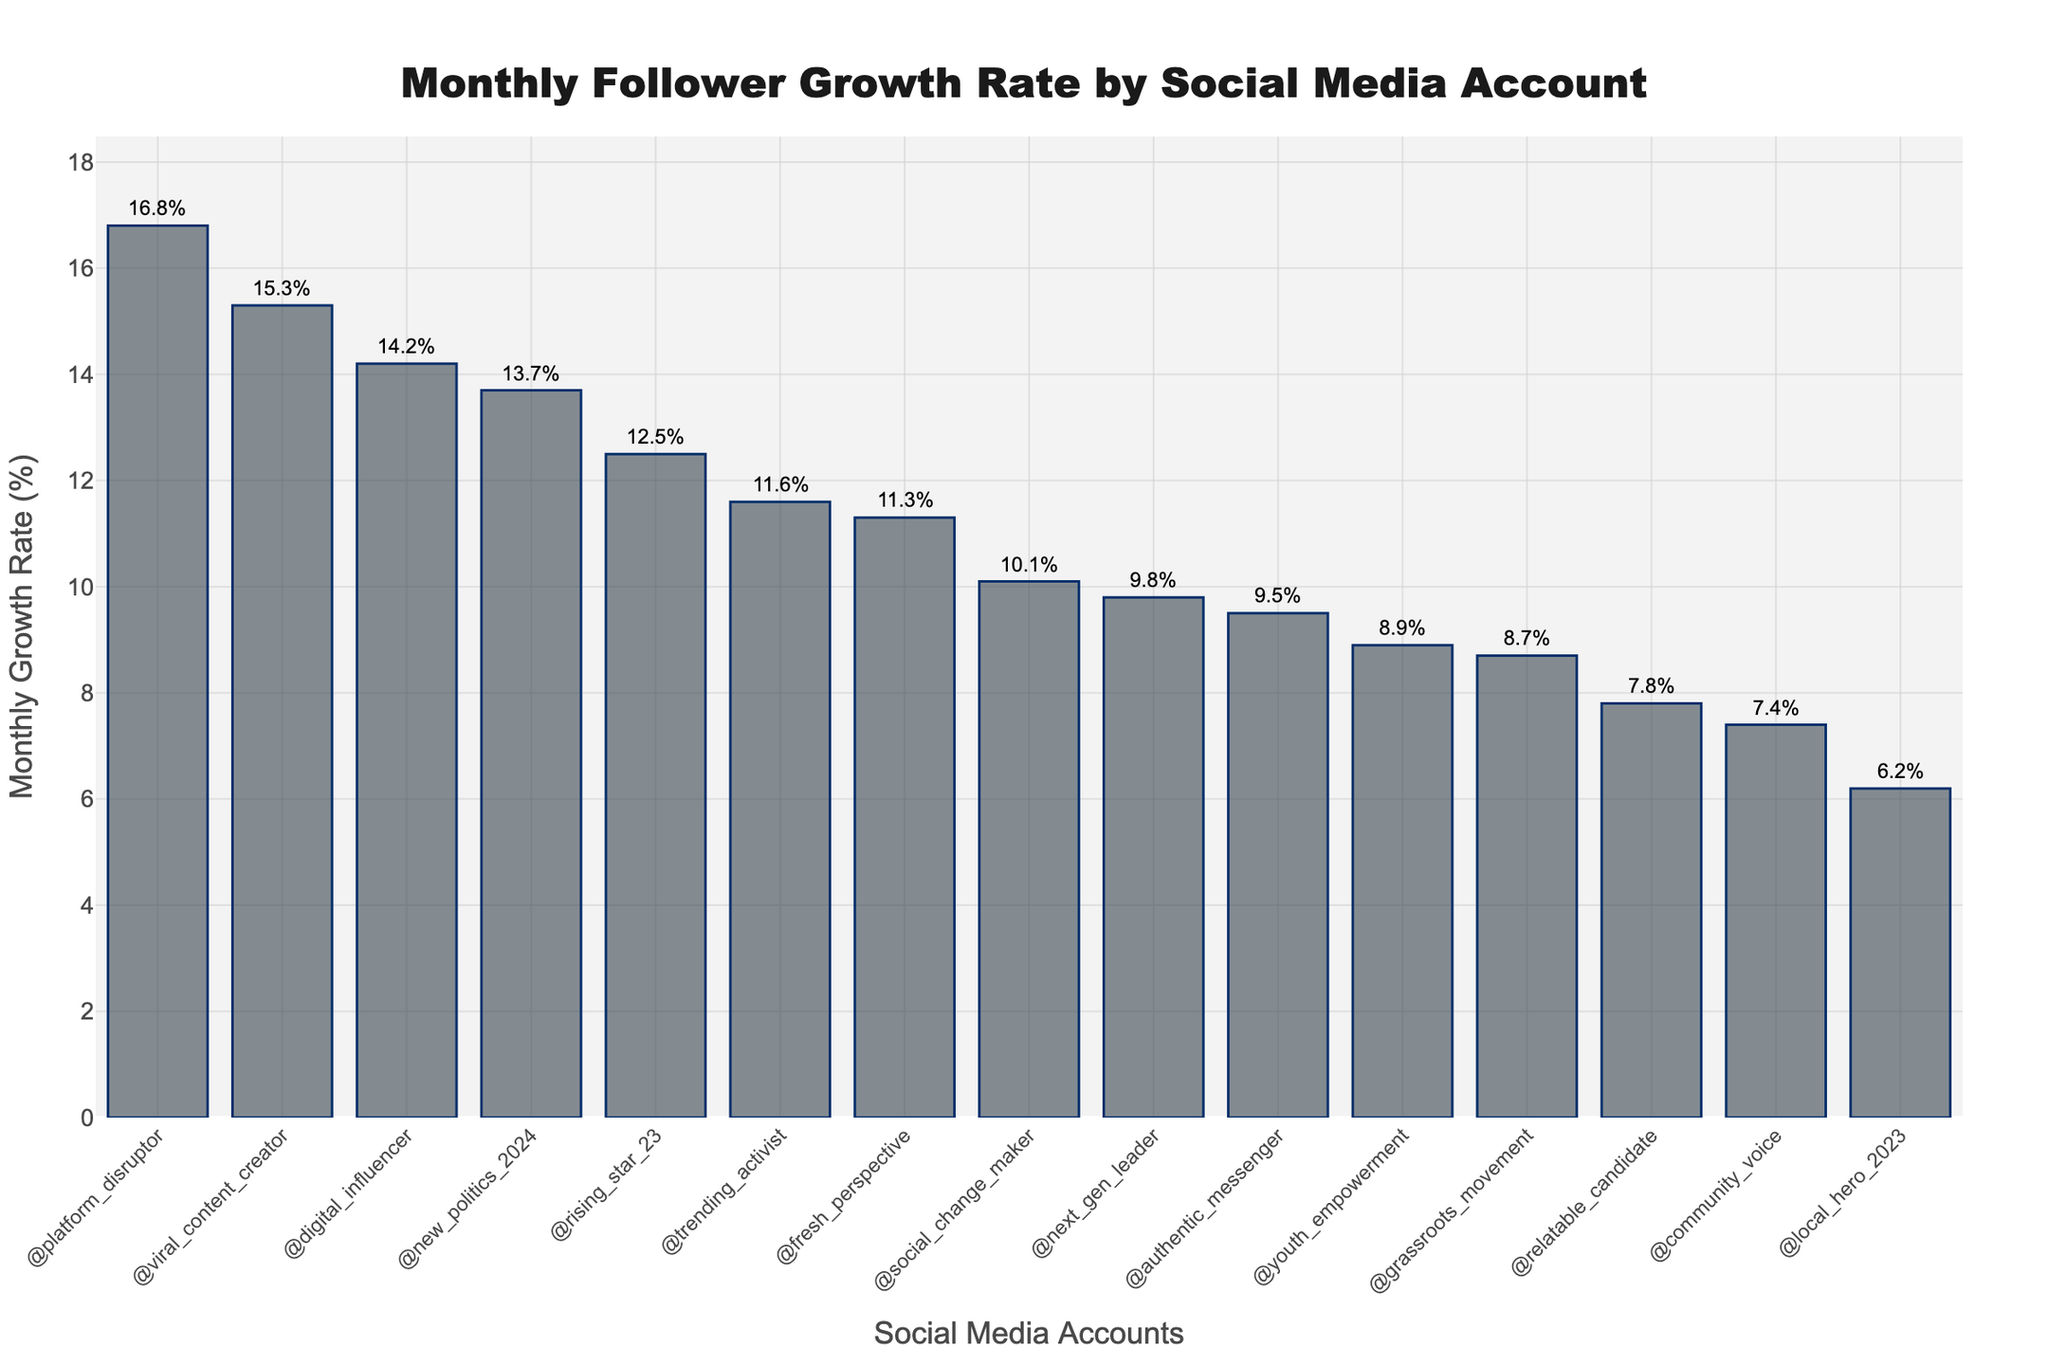Which social media account has the highest monthly follower growth rate? By inspecting the heights of the bars, the tallest bar represents the social media account with the highest growth rate. The account '@platform_disruptor' has the highest growth rate of 16.8%.
Answer: @platform_disruptor Which social media account has the lowest monthly follower growth rate? By inspecting the heights of the bars, the shortest bar represents the social media account with the lowest growth rate. The account '@local_hero_2023' has the lowest growth rate of 6.2%.
Answer: @local_hero_2023 What is the difference in monthly follower growth rates between @platform_disruptor and @local_hero_2023? The growth rates for '@platform_disruptor' and '@local_hero_2023' are 16.8% and 6.2%, respectively. Subtracting these values: 16.8% - 6.2% = 10.6%.
Answer: 10.6% Which account is growing faster, @rising_star_23 or @social_change_maker? Comparing the heights of the bars for '@rising_star_23' and '@social_change_maker', we see that '@rising_star_23' has a growth rate of 12.5% and '@social_change_maker' has a growth rate of 10.1%. Since 12.5% > 10.1%, '@rising_star_23' is growing faster.
Answer: @rising_star_23 What is the average monthly follower growth rate for all accounts? To find the average, sum all growth rates and divide by the number of accounts. The sum is 12.5 + 8.7 + 15.3 + 6.2 + 9.8 + 7.4 + 11.6 + 10.1 + 14.2 + 8.9 + 13.7 + 9.5 + 16.8 + 7.8 + 11.3 = 164.8%. There are 15 accounts, so the average is 164.8 / 15 ≈ 11.0%.
Answer: 11.0% How many accounts have a monthly growth rate greater than 10%? By identifying the bars whose heights correspond to a rate greater than 10%, we find 9 accounts: '@rising_star_23', '@viral_content_creator', '@next_gen_leader', '@trending_activist', '@social_change_maker', '@digital_influencer', '@new_politics_2024', '@platform_disruptor', and '@fresh_perspective'.
Answer: 9 What is the median monthly follower growth rate? To find the median, first, list all growth rates in ascending order: 6.2%, 7.4%, 7.8%, 8.7%, 8.9%, 9.5%, 9.8%, 10.1%, 11.3%, 11.6%, 12.5%, 13.7%, 14.2%, 15.3%, 16.8%. The median is the 8th value since there are 15 values in total. Hence, the median growth rate is 10.1%.
Answer: 10.1% Which account has a growth rate closest to the median value? The median growth rate is 10.1%. By inspecting the rates, '@social_change_maker' has a growth rate of 10.1%, which is exactly the median value.
Answer: @social_change_maker 